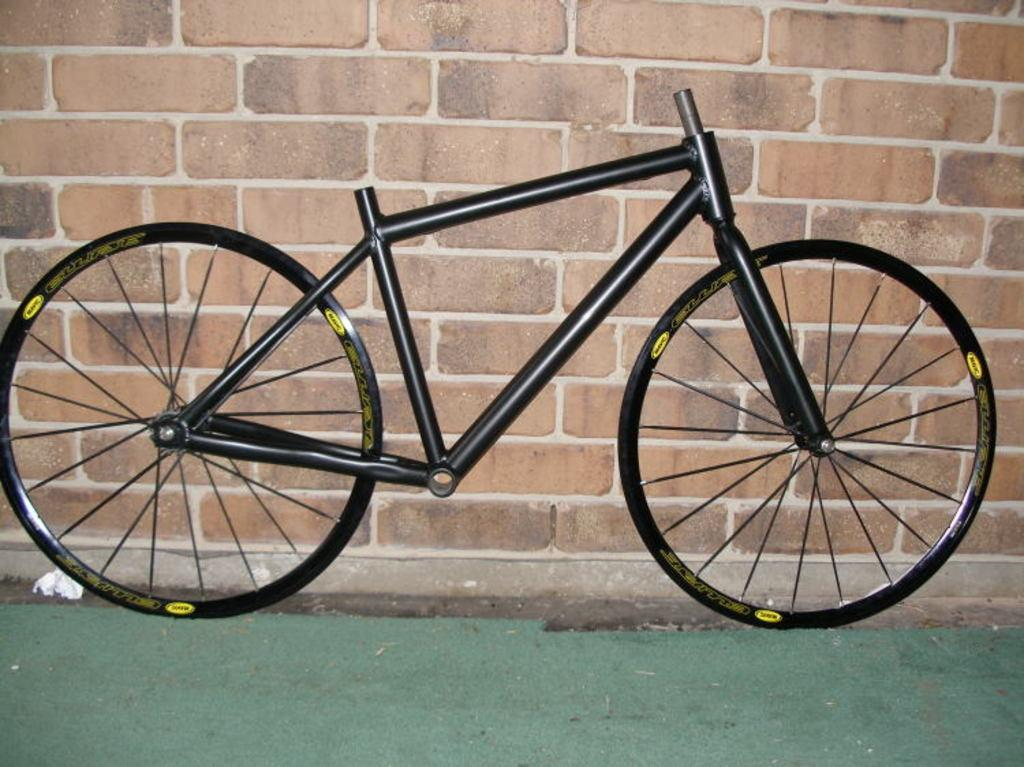What is the main subject of the image? The main subject of the image is a skeleton of a bike. What can be seen in the background of the image? There is a wall in the background of the image. What type of flooring is visible in the image? There is a green carpet floor in the image. What type of music is the band playing in the image? There is no band present in the image, so it is not possible to determine what type of music they might be playing. 